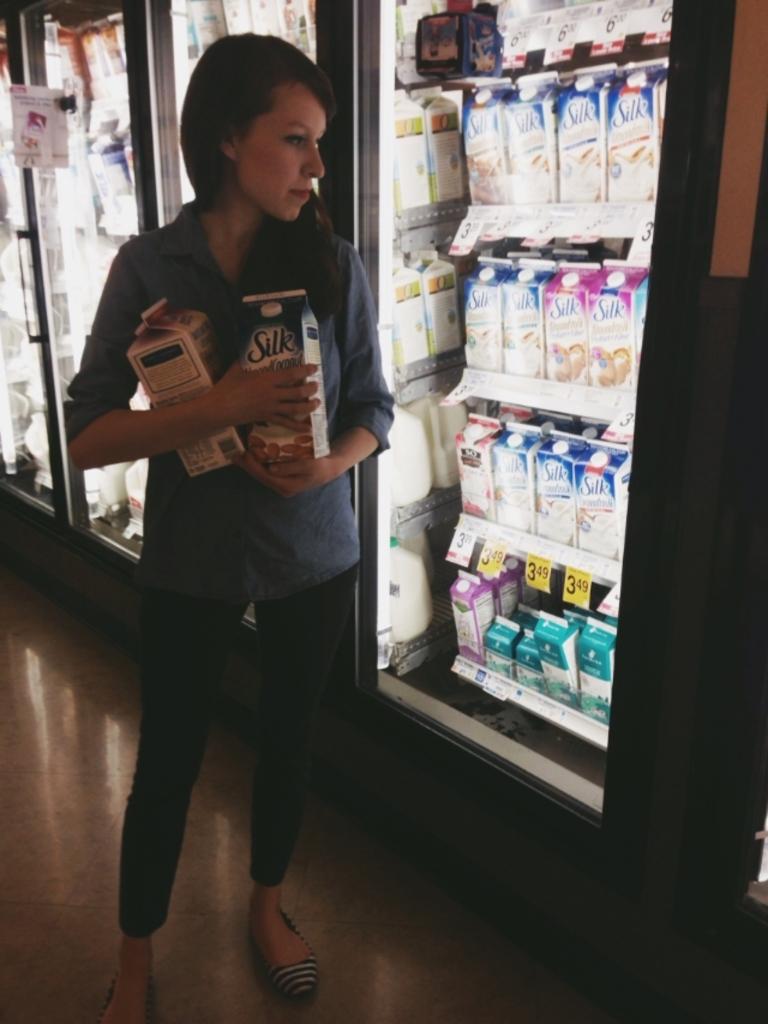What brand of milk is she buying?
Offer a terse response. Silk. 